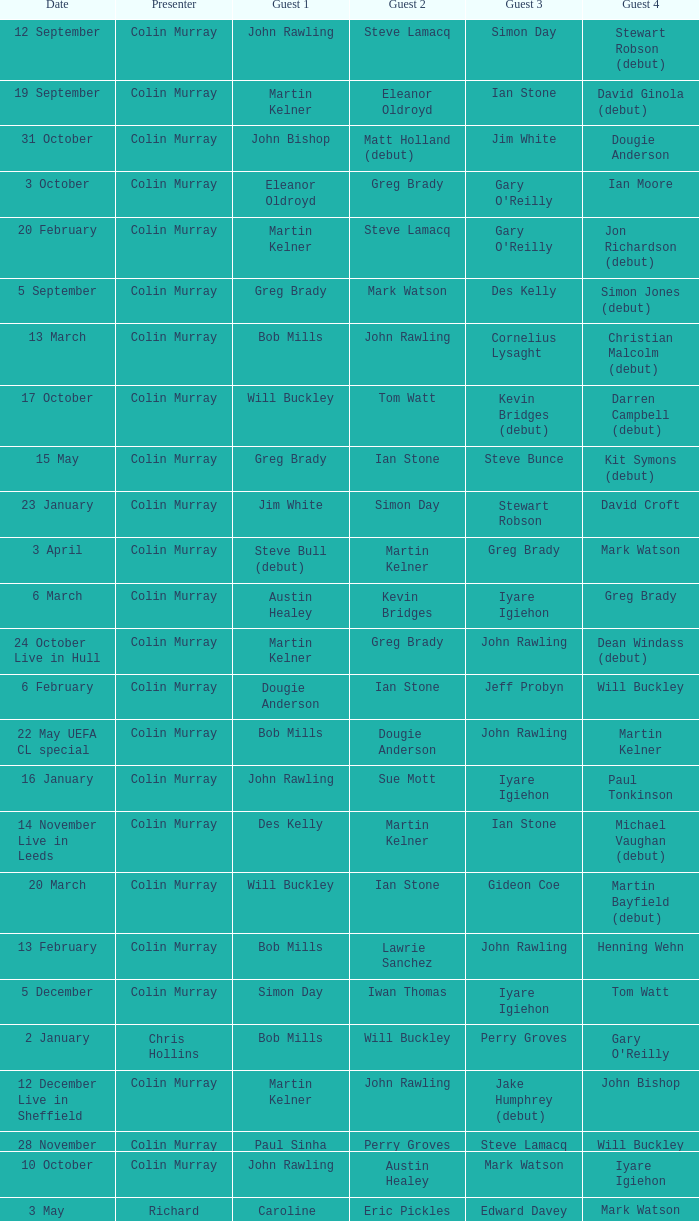How many people are guest 1 on episodes where guest 4 is Des Kelly? 1.0. Write the full table. {'header': ['Date', 'Presenter', 'Guest 1', 'Guest 2', 'Guest 3', 'Guest 4'], 'rows': [['12 September', 'Colin Murray', 'John Rawling', 'Steve Lamacq', 'Simon Day', 'Stewart Robson (debut)'], ['19 September', 'Colin Murray', 'Martin Kelner', 'Eleanor Oldroyd', 'Ian Stone', 'David Ginola (debut)'], ['31 October', 'Colin Murray', 'John Bishop', 'Matt Holland (debut)', 'Jim White', 'Dougie Anderson'], ['3 October', 'Colin Murray', 'Eleanor Oldroyd', 'Greg Brady', "Gary O'Reilly", 'Ian Moore'], ['20 February', 'Colin Murray', 'Martin Kelner', 'Steve Lamacq', "Gary O'Reilly", 'Jon Richardson (debut)'], ['5 September', 'Colin Murray', 'Greg Brady', 'Mark Watson', 'Des Kelly', 'Simon Jones (debut)'], ['13 March', 'Colin Murray', 'Bob Mills', 'John Rawling', 'Cornelius Lysaght', 'Christian Malcolm (debut)'], ['17 October', 'Colin Murray', 'Will Buckley', 'Tom Watt', 'Kevin Bridges (debut)', 'Darren Campbell (debut)'], ['15 May', 'Colin Murray', 'Greg Brady', 'Ian Stone', 'Steve Bunce', 'Kit Symons (debut)'], ['23 January', 'Colin Murray', 'Jim White', 'Simon Day', 'Stewart Robson', 'David Croft'], ['3 April', 'Colin Murray', 'Steve Bull (debut)', 'Martin Kelner', 'Greg Brady', 'Mark Watson'], ['6 March', 'Colin Murray', 'Austin Healey', 'Kevin Bridges', 'Iyare Igiehon', 'Greg Brady'], ['24 October Live in Hull', 'Colin Murray', 'Martin Kelner', 'Greg Brady', 'John Rawling', 'Dean Windass (debut)'], ['6 February', 'Colin Murray', 'Dougie Anderson', 'Ian Stone', 'Jeff Probyn', 'Will Buckley'], ['22 May UEFA CL special', 'Colin Murray', 'Bob Mills', 'Dougie Anderson', 'John Rawling', 'Martin Kelner'], ['16 January', 'Colin Murray', 'John Rawling', 'Sue Mott', 'Iyare Igiehon', 'Paul Tonkinson'], ['14 November Live in Leeds', 'Colin Murray', 'Des Kelly', 'Martin Kelner', 'Ian Stone', 'Michael Vaughan (debut)'], ['20 March', 'Colin Murray', 'Will Buckley', 'Ian Stone', 'Gideon Coe', 'Martin Bayfield (debut)'], ['13 February', 'Colin Murray', 'Bob Mills', 'Lawrie Sanchez', 'John Rawling', 'Henning Wehn'], ['5 December', 'Colin Murray', 'Simon Day', 'Iwan Thomas', 'Iyare Igiehon', 'Tom Watt'], ['2 January', 'Chris Hollins', 'Bob Mills', 'Will Buckley', 'Perry Groves', "Gary O'Reilly"], ['12 December Live in Sheffield', 'Colin Murray', 'Martin Kelner', 'John Rawling', 'Jake Humphrey (debut)', 'John Bishop'], ['28 November', 'Colin Murray', 'Paul Sinha', 'Perry Groves', 'Steve Lamacq', 'Will Buckley'], ['10 October', 'Colin Murray', 'John Rawling', 'Austin Healey', 'Mark Watson', 'Iyare Igiehon'], ['3 May Election special', 'Richard Bacon', 'Caroline Flint (debut) ( Labour )', 'Eric Pickles (debut) ( Conservative )', 'Edward Davey (debut) ( Lib Dem )', 'Mark Watson'], ['8 May', 'Colin Murray', 'Andy Parsons', 'Martin Kelner', 'Sue Mott', 'Des Kelly'], ['19 December', 'Colin Murray', 'Dougie Anderson', 'Greg Brady', 'Gideon Coe (debut)', 'Ian Stone'], ['21 November', 'Colin Murray', 'Greg Brady', 'David Croft', 'Eleanor Oldroyd', 'Henning Wehn'], ['30 January', 'Colin Murray', 'Greg Brady', 'Tom Watt', 'Matt Holland', 'John Bishop'], ["24 April Runners' special", 'Colin Murray', 'Kriss Akabusi', 'Roger Black', 'Katharine Merry (debut)', 'Simon Day'], ['1 May', 'Colin Murray', 'John Rawling', 'Nihal', 'Kevin Bridges', 'Tom Watt'], ['26 September', 'Colin Murray', 'Dougie Anderson', 'Will Buckley', 'Jim White', 'Alun Cochrane (debut)'], ['27 March', 'Colin Murray', 'Steve Bunce', 'Eleanor Oldroyd', 'Jim White', 'Simon Day'], ['27 February', 'Colin Murray', 'Perry Groves', 'Des Kelly', 'Iwan Thomas', 'Ian Moore'], ['9 January', 'Alan Davies', 'Eleanor Oldroyd', 'Martin Kelner', 'Des Kelly', 'Mark Watson'], ['26 December Comedians special', 'Colin Murray', 'Jim Jeffries', 'Bob Mills', 'John Bishop', 'Dara Ó Briain (debut)'], ['17 April', 'Colin Murray', 'Henning Wehn', "Gary O'Reilly", 'Darren Campbell', 'Dougie Anderson'], ['7 November', 'Colin Murray', 'Gail Emms', 'Jeff Probyn', "Gary O'Reilly", 'Terry Alderton (debut)']]} 